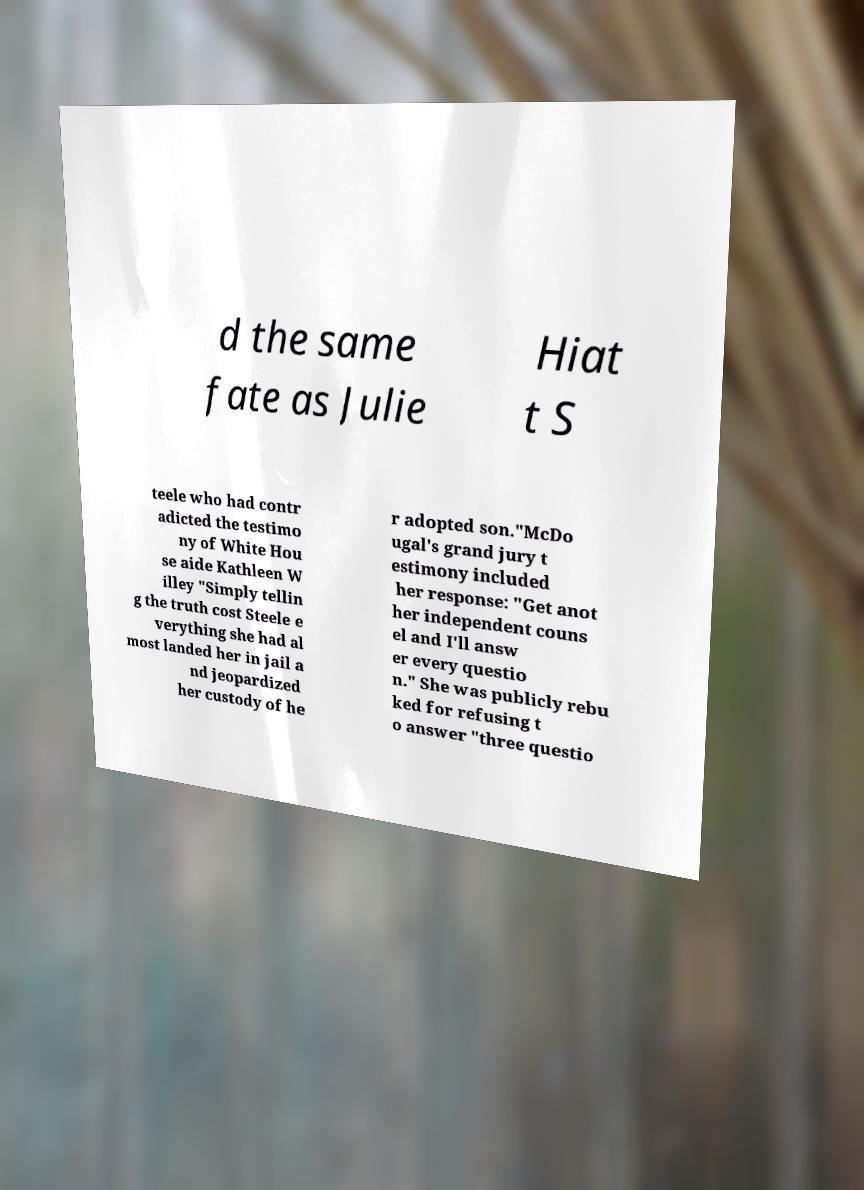There's text embedded in this image that I need extracted. Can you transcribe it verbatim? d the same fate as Julie Hiat t S teele who had contr adicted the testimo ny of White Hou se aide Kathleen W illey "Simply tellin g the truth cost Steele e verything she had al most landed her in jail a nd jeopardized her custody of he r adopted son."McDo ugal's grand jury t estimony included her response: "Get anot her independent couns el and I'll answ er every questio n." She was publicly rebu ked for refusing t o answer "three questio 